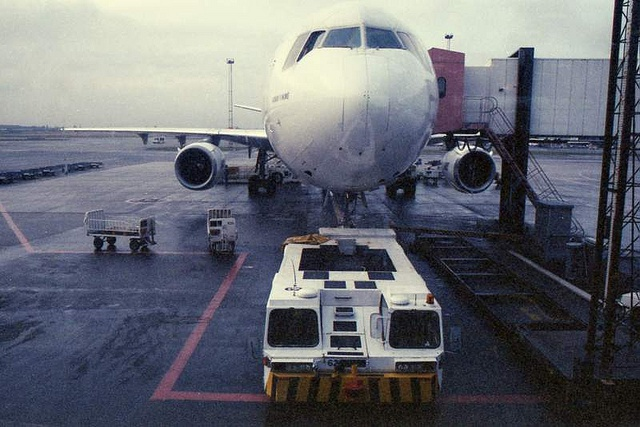Describe the objects in this image and their specific colors. I can see airplane in beige, darkgray, and gray tones, truck in beige, black, darkgray, lightgray, and gray tones, and truck in beige, gray, and black tones in this image. 